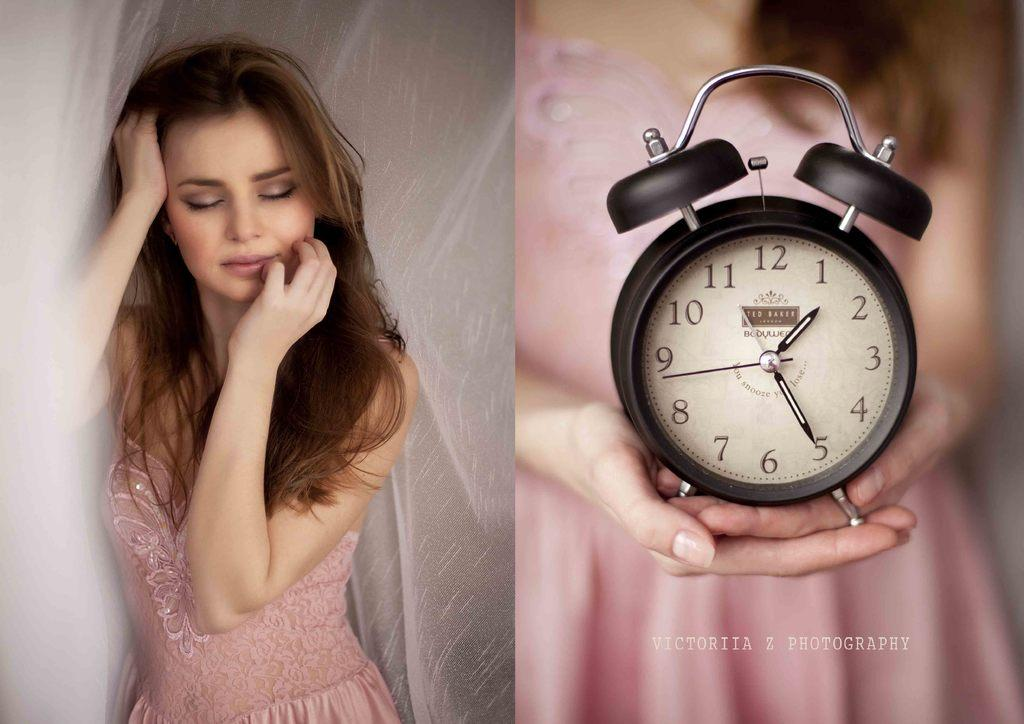<image>
Offer a succinct explanation of the picture presented. A beautiful women sleeping, and then holding a Ted Baker alarm clock. 